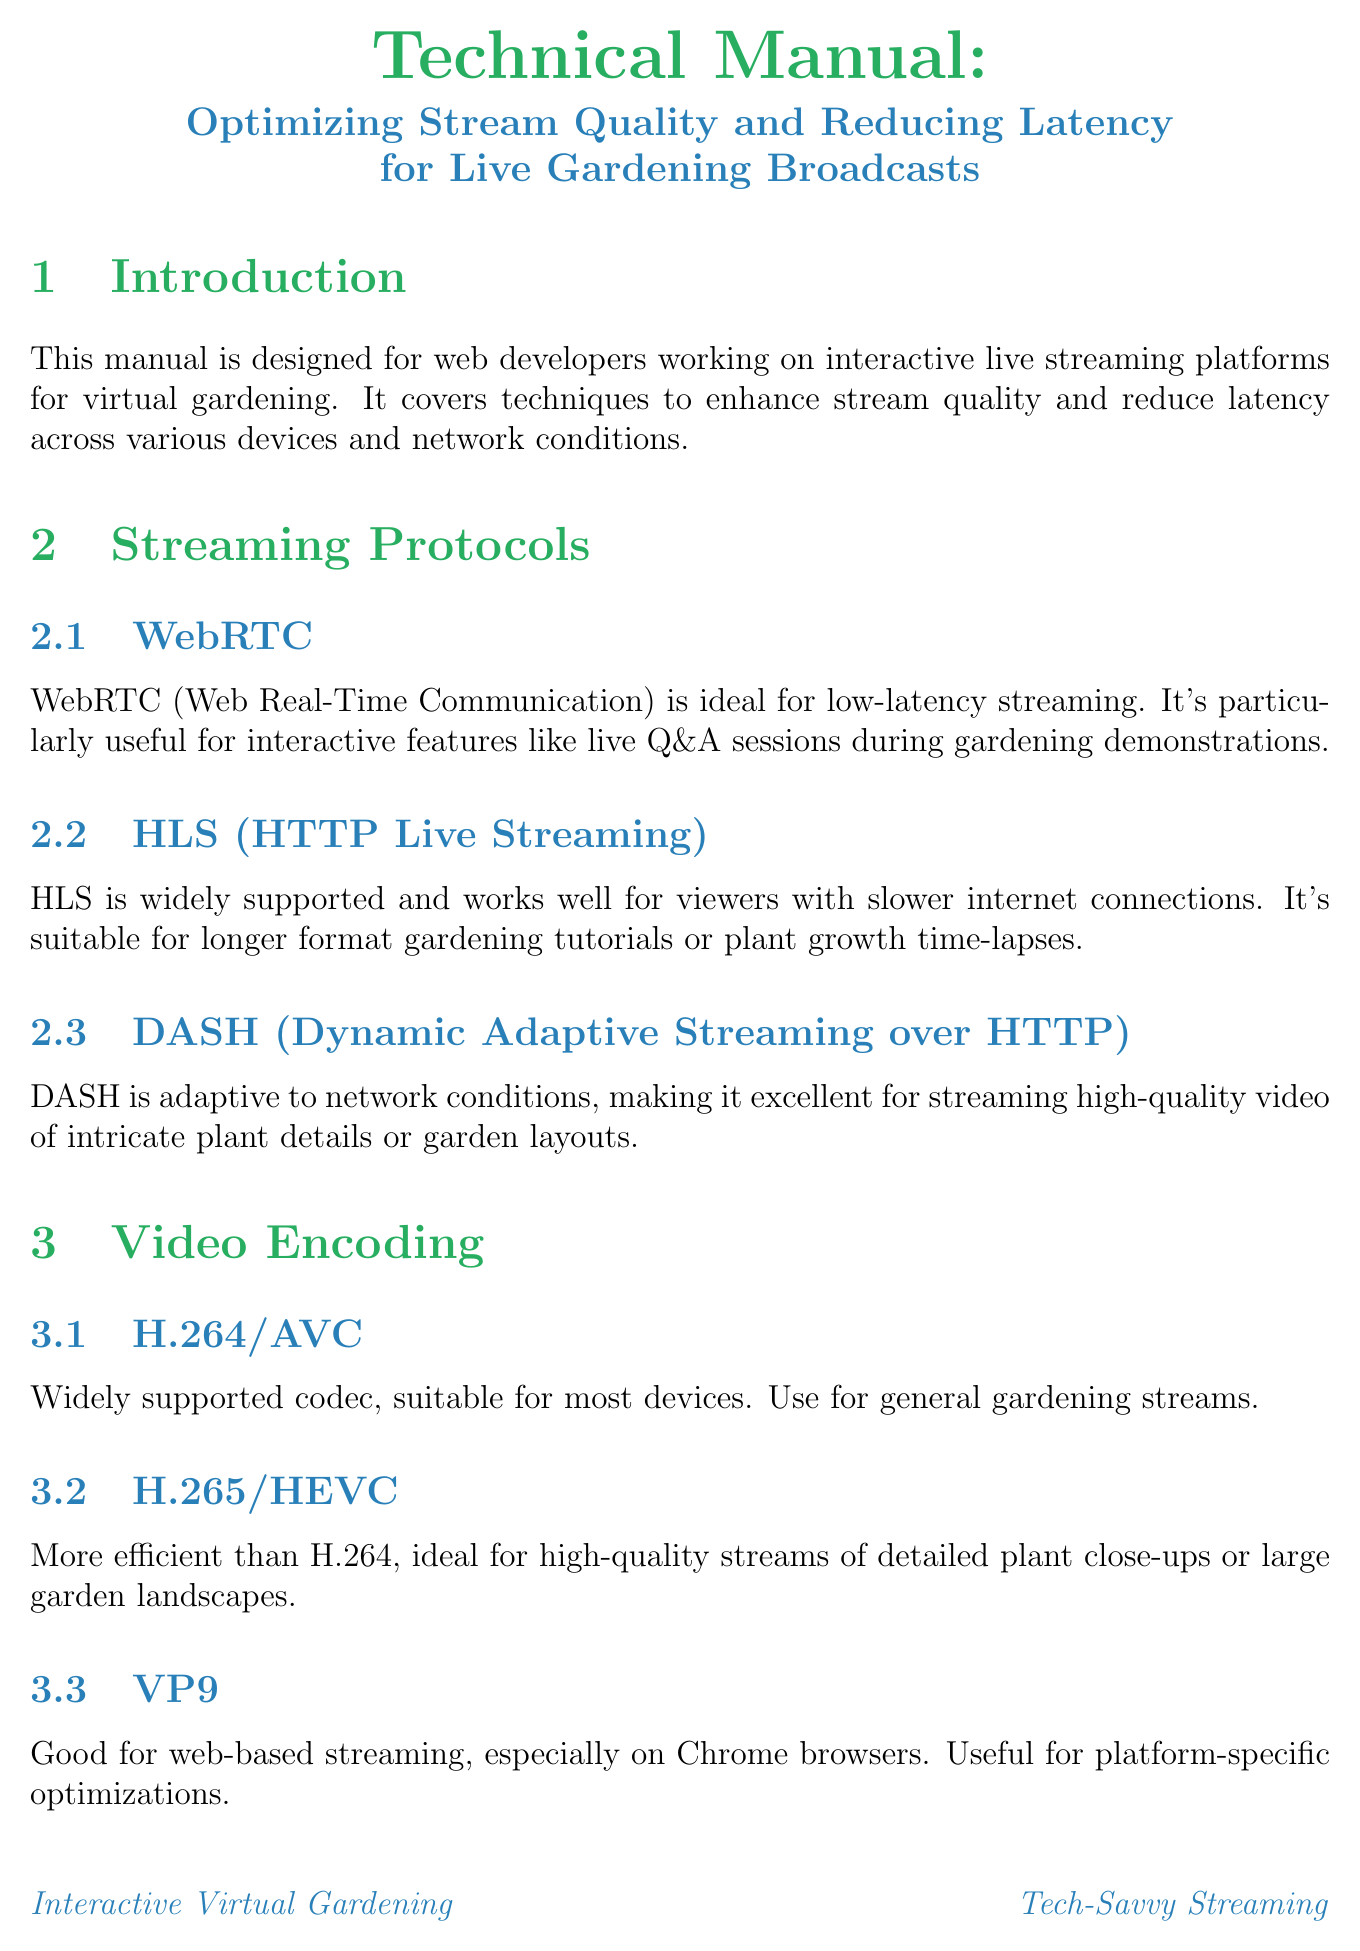what is the title of the manual? The title of the manual is provided at the beginning of the document, which specifies the focus on stream quality and latency reduction.
Answer: Technical Manual: Optimizing Stream Quality and Reducing Latency for Live Gardening Broadcasts what is the main streaming protocol discussed for low-latency? The document highlights specific streaming protocols suited for various situations, with WebRTC being the one noted for low-latency streaming.
Answer: WebRTC what type of CDN is suggested for latency reduction? The manual identifies Content Delivery Networks as a solution for reducing latency and names specific providers.
Answer: Cloudflare or Amazon CloudFront how does Adaptive Bitrate Streaming work? The document explains that this technique adjusts streaming quality automatically based on viewer network conditions, ensuring optimal playback.
Answer: Adjusts video quality what is a recommended video encoding format for high-quality streams? The document lists various encoding formats and indicates H.265/HEVC as the more efficient option for high-quality streams.
Answer: H.265/HEVC what is one interactive feature implemented for live Q&A sessions? The manual describes interactive features that enhance engagement, with a specific mention of a real-time interaction method.
Answer: WebSocket-based chat name one device-specific optimization mentioned for mobile devices. The document outlines optimizations tailored to different devices, specifically noting an approach for mobile devices in terms of video format.
Answer: Vertical video formats what should be monitored for optimizing streaming performance? The manual emphasizes the importance of integrating certain tools to gather data that helps improve streaming quality and user experience.
Answer: Stream health what fallback mechanism is suggested for poor connections? The document advises on options available for viewers with poor connections to ensure participation in broadcasts.
Answer: Static images or lower resolution streams 